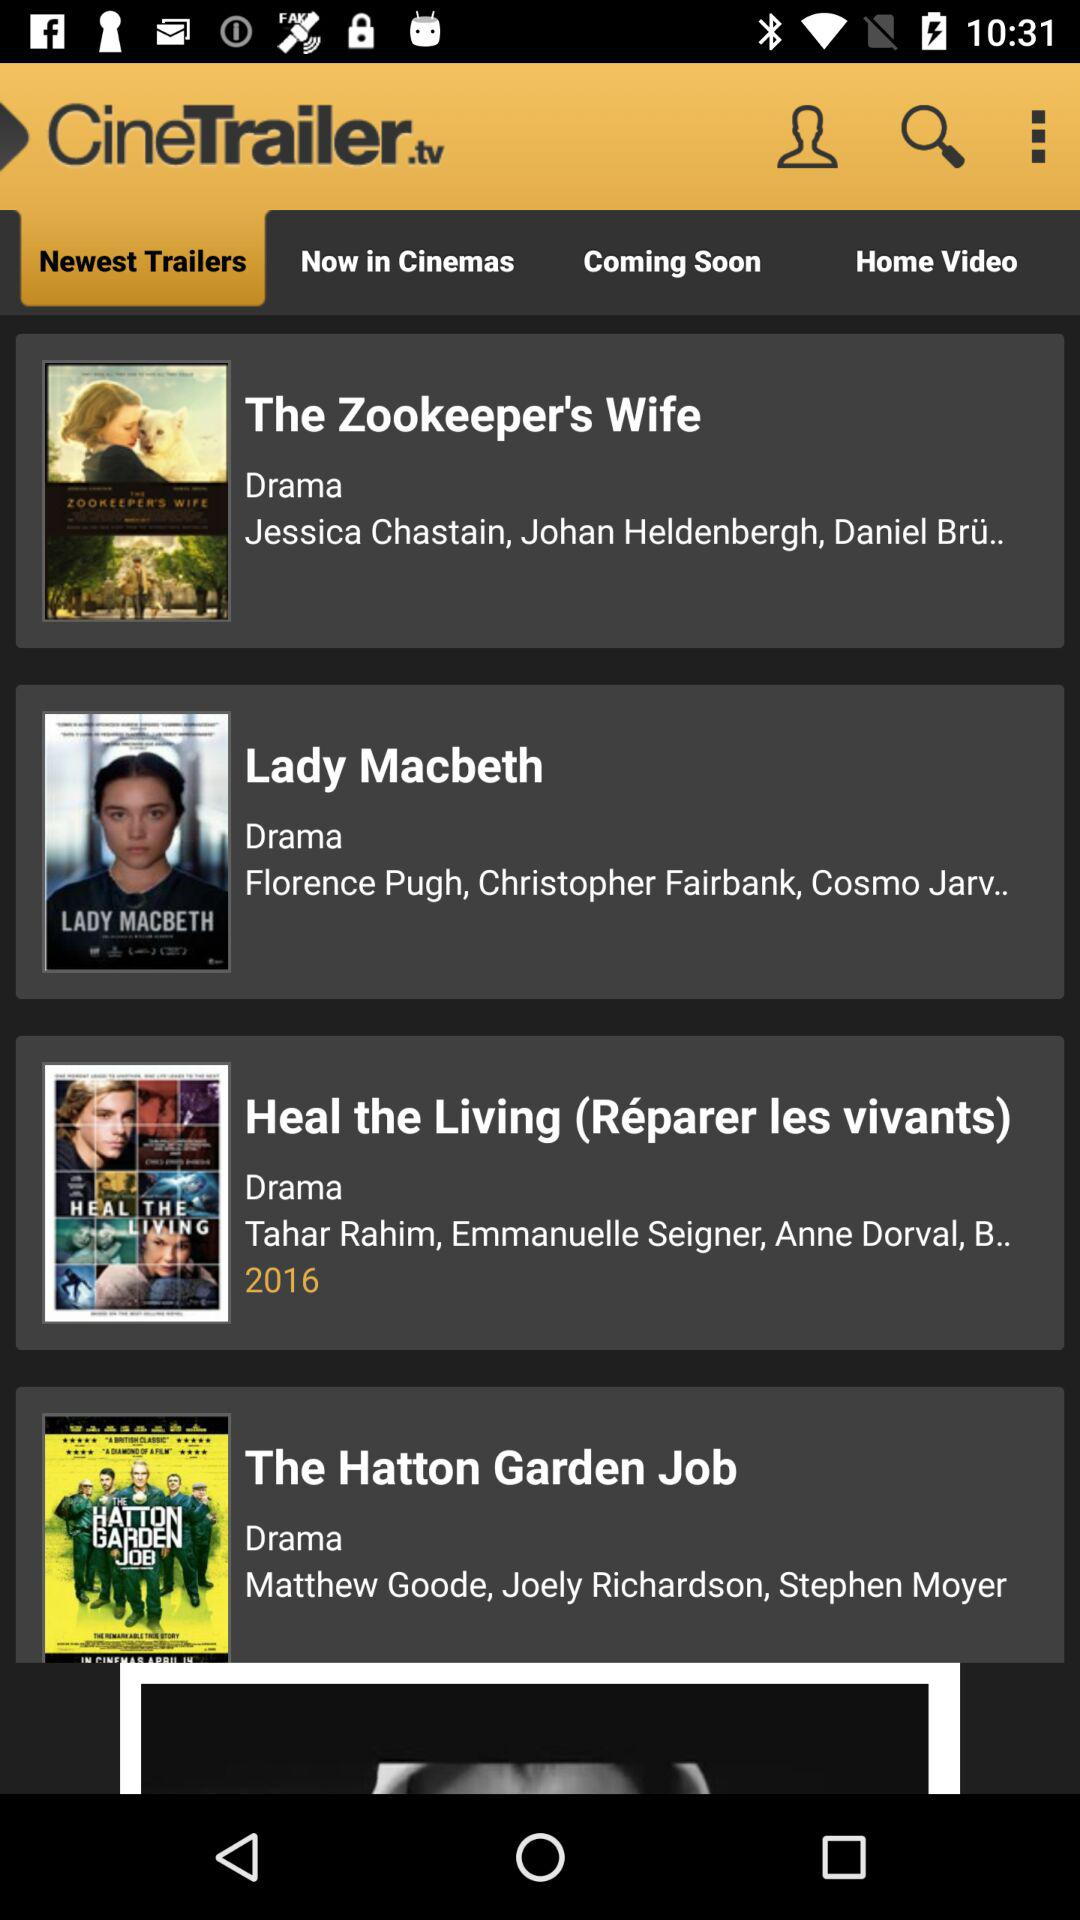What is the application name? The application name is "CineTrailer.tv". 